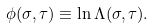<formula> <loc_0><loc_0><loc_500><loc_500>\phi ( \sigma , \tau ) \equiv \ln \Lambda ( \sigma , \tau ) .</formula> 